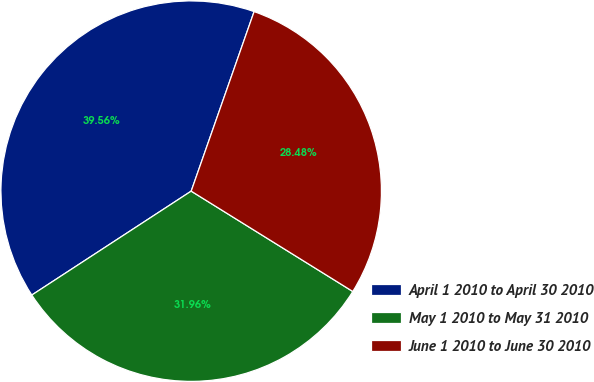Convert chart to OTSL. <chart><loc_0><loc_0><loc_500><loc_500><pie_chart><fcel>April 1 2010 to April 30 2010<fcel>May 1 2010 to May 31 2010<fcel>June 1 2010 to June 30 2010<nl><fcel>39.56%<fcel>31.96%<fcel>28.48%<nl></chart> 